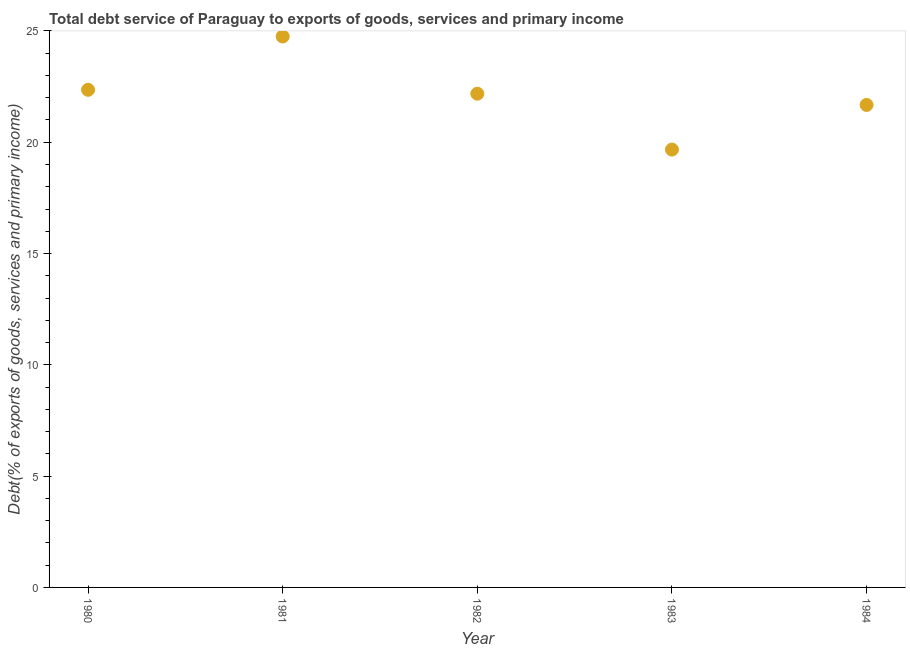What is the total debt service in 1981?
Offer a terse response. 24.75. Across all years, what is the maximum total debt service?
Your response must be concise. 24.75. Across all years, what is the minimum total debt service?
Offer a very short reply. 19.67. What is the sum of the total debt service?
Offer a very short reply. 110.64. What is the difference between the total debt service in 1982 and 1984?
Your answer should be compact. 0.51. What is the average total debt service per year?
Provide a succinct answer. 22.13. What is the median total debt service?
Offer a terse response. 22.18. In how many years, is the total debt service greater than 2 %?
Make the answer very short. 5. What is the ratio of the total debt service in 1980 to that in 1984?
Your answer should be compact. 1.03. Is the difference between the total debt service in 1980 and 1981 greater than the difference between any two years?
Make the answer very short. No. What is the difference between the highest and the second highest total debt service?
Keep it short and to the point. 2.4. What is the difference between the highest and the lowest total debt service?
Make the answer very short. 5.08. In how many years, is the total debt service greater than the average total debt service taken over all years?
Your response must be concise. 3. Does the total debt service monotonically increase over the years?
Offer a very short reply. No. Does the graph contain grids?
Provide a short and direct response. No. What is the title of the graph?
Your answer should be very brief. Total debt service of Paraguay to exports of goods, services and primary income. What is the label or title of the Y-axis?
Your response must be concise. Debt(% of exports of goods, services and primary income). What is the Debt(% of exports of goods, services and primary income) in 1980?
Offer a very short reply. 22.36. What is the Debt(% of exports of goods, services and primary income) in 1981?
Offer a very short reply. 24.75. What is the Debt(% of exports of goods, services and primary income) in 1982?
Keep it short and to the point. 22.18. What is the Debt(% of exports of goods, services and primary income) in 1983?
Keep it short and to the point. 19.67. What is the Debt(% of exports of goods, services and primary income) in 1984?
Your response must be concise. 21.68. What is the difference between the Debt(% of exports of goods, services and primary income) in 1980 and 1981?
Ensure brevity in your answer.  -2.4. What is the difference between the Debt(% of exports of goods, services and primary income) in 1980 and 1982?
Keep it short and to the point. 0.18. What is the difference between the Debt(% of exports of goods, services and primary income) in 1980 and 1983?
Offer a very short reply. 2.69. What is the difference between the Debt(% of exports of goods, services and primary income) in 1980 and 1984?
Give a very brief answer. 0.68. What is the difference between the Debt(% of exports of goods, services and primary income) in 1981 and 1982?
Your answer should be very brief. 2.57. What is the difference between the Debt(% of exports of goods, services and primary income) in 1981 and 1983?
Provide a short and direct response. 5.08. What is the difference between the Debt(% of exports of goods, services and primary income) in 1981 and 1984?
Give a very brief answer. 3.08. What is the difference between the Debt(% of exports of goods, services and primary income) in 1982 and 1983?
Ensure brevity in your answer.  2.51. What is the difference between the Debt(% of exports of goods, services and primary income) in 1982 and 1984?
Give a very brief answer. 0.51. What is the difference between the Debt(% of exports of goods, services and primary income) in 1983 and 1984?
Provide a short and direct response. -2. What is the ratio of the Debt(% of exports of goods, services and primary income) in 1980 to that in 1981?
Provide a succinct answer. 0.9. What is the ratio of the Debt(% of exports of goods, services and primary income) in 1980 to that in 1983?
Make the answer very short. 1.14. What is the ratio of the Debt(% of exports of goods, services and primary income) in 1980 to that in 1984?
Keep it short and to the point. 1.03. What is the ratio of the Debt(% of exports of goods, services and primary income) in 1981 to that in 1982?
Your answer should be very brief. 1.12. What is the ratio of the Debt(% of exports of goods, services and primary income) in 1981 to that in 1983?
Keep it short and to the point. 1.26. What is the ratio of the Debt(% of exports of goods, services and primary income) in 1981 to that in 1984?
Keep it short and to the point. 1.14. What is the ratio of the Debt(% of exports of goods, services and primary income) in 1982 to that in 1983?
Offer a terse response. 1.13. What is the ratio of the Debt(% of exports of goods, services and primary income) in 1982 to that in 1984?
Ensure brevity in your answer.  1.02. What is the ratio of the Debt(% of exports of goods, services and primary income) in 1983 to that in 1984?
Provide a short and direct response. 0.91. 